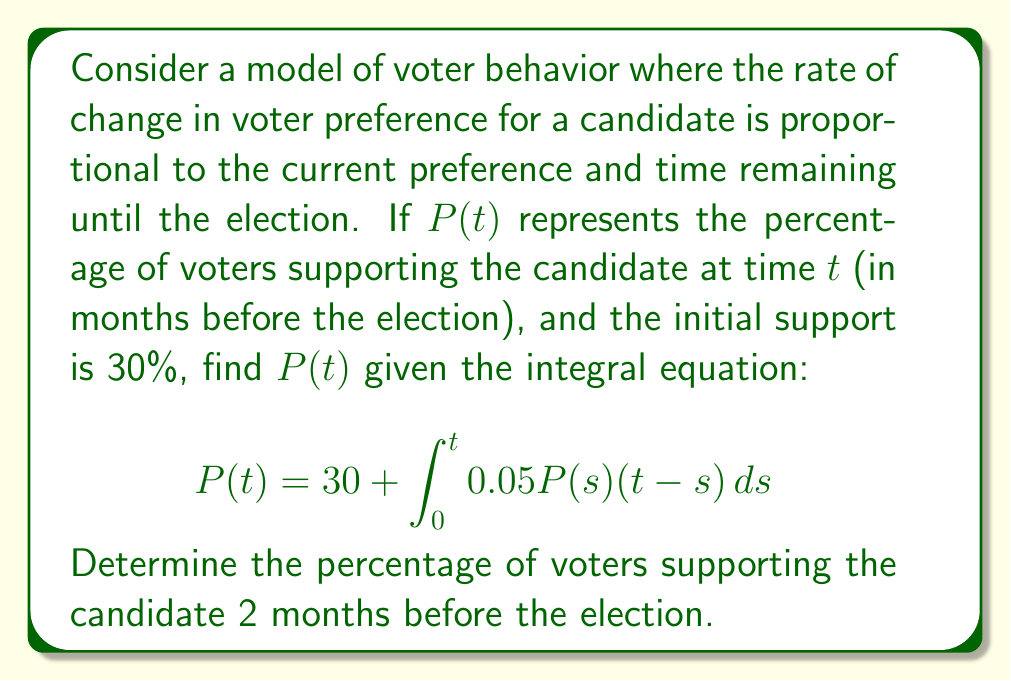What is the answer to this math problem? To solve this integral equation, we'll use the following steps:

1) First, we need to convert the integral equation into a differential equation. Let's differentiate both sides with respect to $t$:

   $$\frac{dP}{dt} = 0 + 0.05P(t)(t-t) + \int_0^t 0.05P(s) ds$$

2) Simplify:

   $$\frac{dP}{dt} = \int_0^t 0.05P(s) ds$$

3) Differentiate again:

   $$\frac{d^2P}{dt^2} = 0.05P(t)$$

4) We now have a second-order linear differential equation. The general solution is:

   $$P(t) = C_1e^{\sqrt{0.05}t} + C_2e^{-\sqrt{0.05}t}$$

5) To find $C_1$ and $C_2$, we use the initial conditions:
   
   At $t=0$, $P(0) = 30$, so:
   $$30 = C_1 + C_2$$

   At $t=0$, $\frac{dP}{dt}(0) = 0$ (from the original integral equation), so:
   $$0 = C_1\sqrt{0.05} - C_2\sqrt{0.05}$$

6) Solving these equations:
   
   $$C_1 = C_2 = 15$$

7) Therefore, the solution is:

   $$P(t) = 15e^{\sqrt{0.05}t} + 15e^{-\sqrt{0.05}t}$$

8) To find the percentage 2 months before the election, we substitute $t=2$:

   $$P(2) = 15e^{\sqrt{0.05}(2)} + 15e^{-\sqrt{0.05}(2)} \approx 31.56$$
Answer: $31.56\%$ 